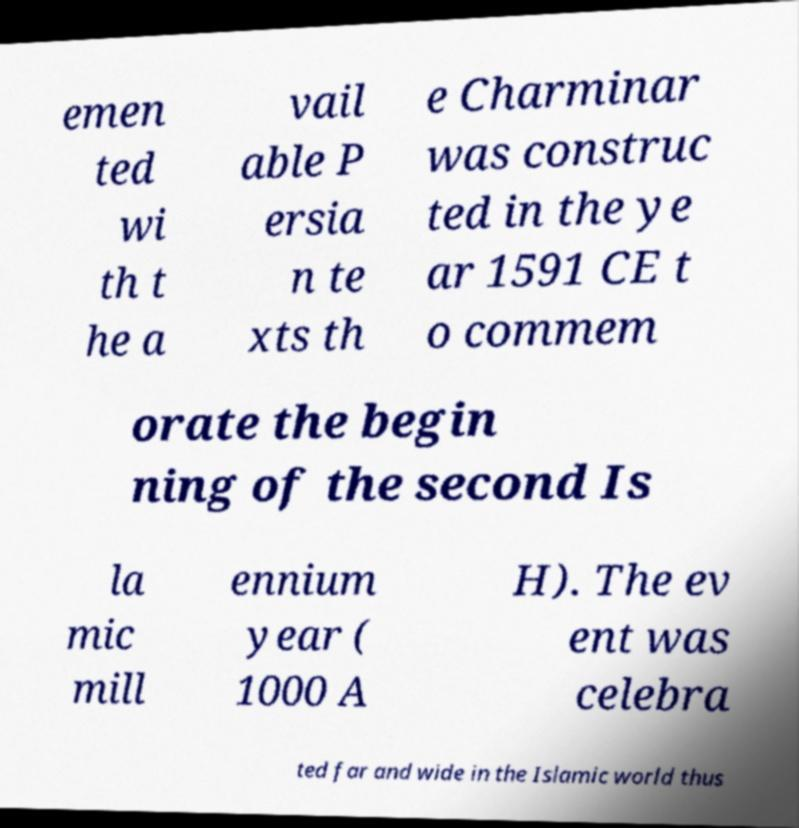There's text embedded in this image that I need extracted. Can you transcribe it verbatim? emen ted wi th t he a vail able P ersia n te xts th e Charminar was construc ted in the ye ar 1591 CE t o commem orate the begin ning of the second Is la mic mill ennium year ( 1000 A H). The ev ent was celebra ted far and wide in the Islamic world thus 